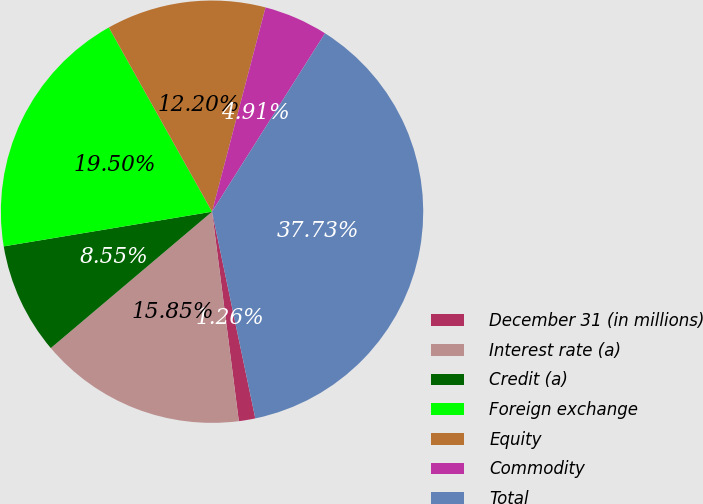Convert chart. <chart><loc_0><loc_0><loc_500><loc_500><pie_chart><fcel>December 31 (in millions)<fcel>Interest rate (a)<fcel>Credit (a)<fcel>Foreign exchange<fcel>Equity<fcel>Commodity<fcel>Total<nl><fcel>1.26%<fcel>15.85%<fcel>8.55%<fcel>19.5%<fcel>12.2%<fcel>4.91%<fcel>37.73%<nl></chart> 